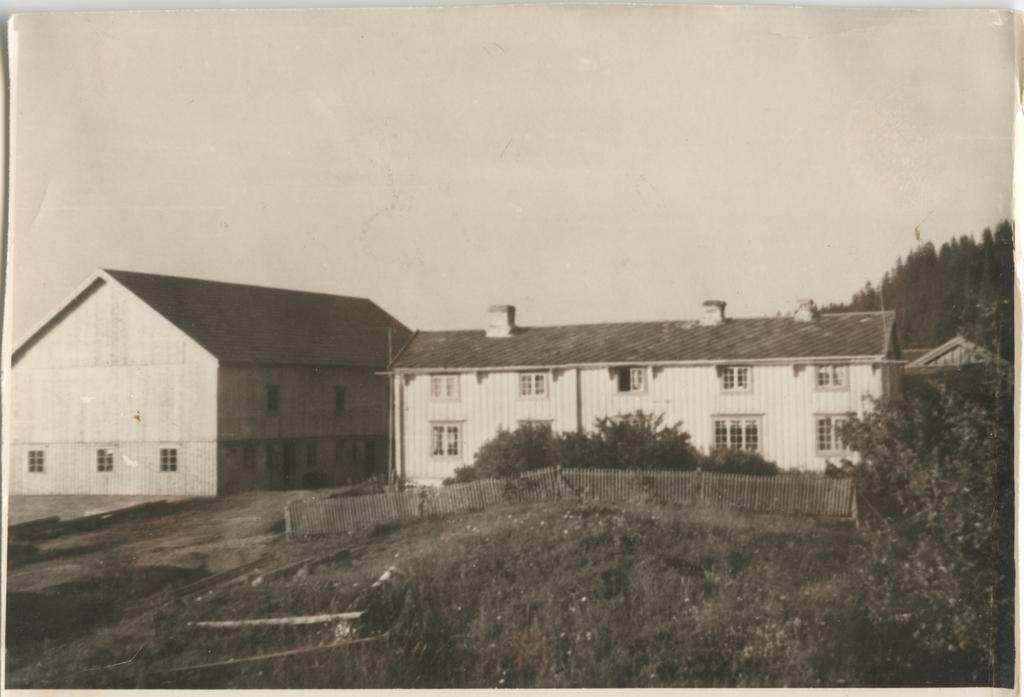What type of structures are visible in the image? There are buildings in the image. What feature do the buildings have? The buildings have windows. What is the purpose of the fence in the image? The fence is present in the image, but its purpose cannot be determined from the facts provided. What type of vegetation is present in the image? Grass and trees are visible in the image. What other living organism can be seen in the image? There is a plant in the image. What part of the natural environment is visible in the image? The sky is visible in the image. Where is the toothbrush located in the image? There is no toothbrush present in the image. What is the chin of the girl doing in the image? There is no girl present in the image, so her chin cannot be observed. 